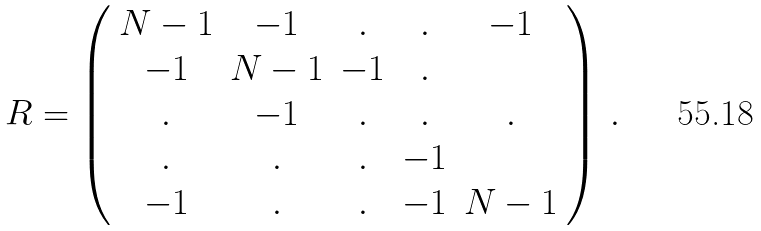<formula> <loc_0><loc_0><loc_500><loc_500>R = \left ( \begin{array} { c c c c c } { N - 1 } & { - 1 } & { . } & { . } & { - 1 } \\ { - 1 } & { N - 1 } & { - 1 } & { . } \\ { . } & { - 1 } & { . } & { . } & { . } \\ { . } & { . } & { . } & { - 1 } \\ { - 1 } & { . } & { . } & { - 1 } & { N - 1 } \end{array} \right ) \, .</formula> 